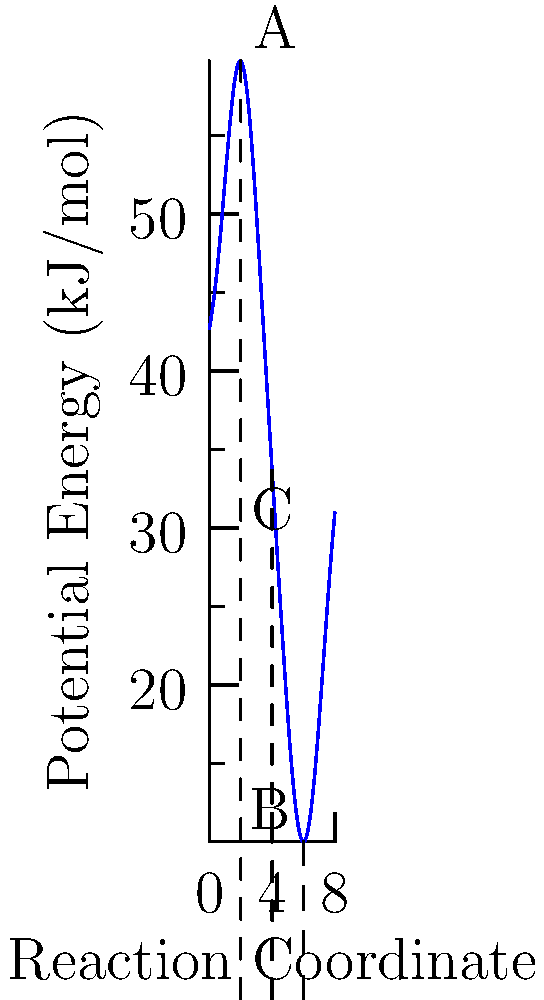Analyze the potential energy surface for a chemical reaction shown in the graph. What is the activation energy for the forward reaction from A to B, and what type of stationary point does C represent? To answer this question, we need to analyze the potential energy surface:

1. Identify key points:
   A: reactant state
   B: product state
   C: highest point between A and B

2. Calculate activation energy:
   - Activation energy is the energy difference between the reactant state and the highest point on the reaction path.
   - From the graph, A is at approximately 60 kJ/mol.
   - The highest point (C) is at approximately 70 kJ/mol.
   - Activation energy = 70 kJ/mol - 60 kJ/mol = 10 kJ/mol

3. Analyze point C:
   - C is the highest point between A and B.
   - It represents the transition state of the reaction.
   - In terms of stationary points, C is a maximum on the reaction coordinate but a minimum in all other directions.
   - This type of stationary point is called a saddle point.

Therefore, the activation energy for the forward reaction from A to B is approximately 10 kJ/mol, and C represents a saddle point on the potential energy surface.
Answer: Activation energy ≈ 10 kJ/mol; C is a saddle point. 